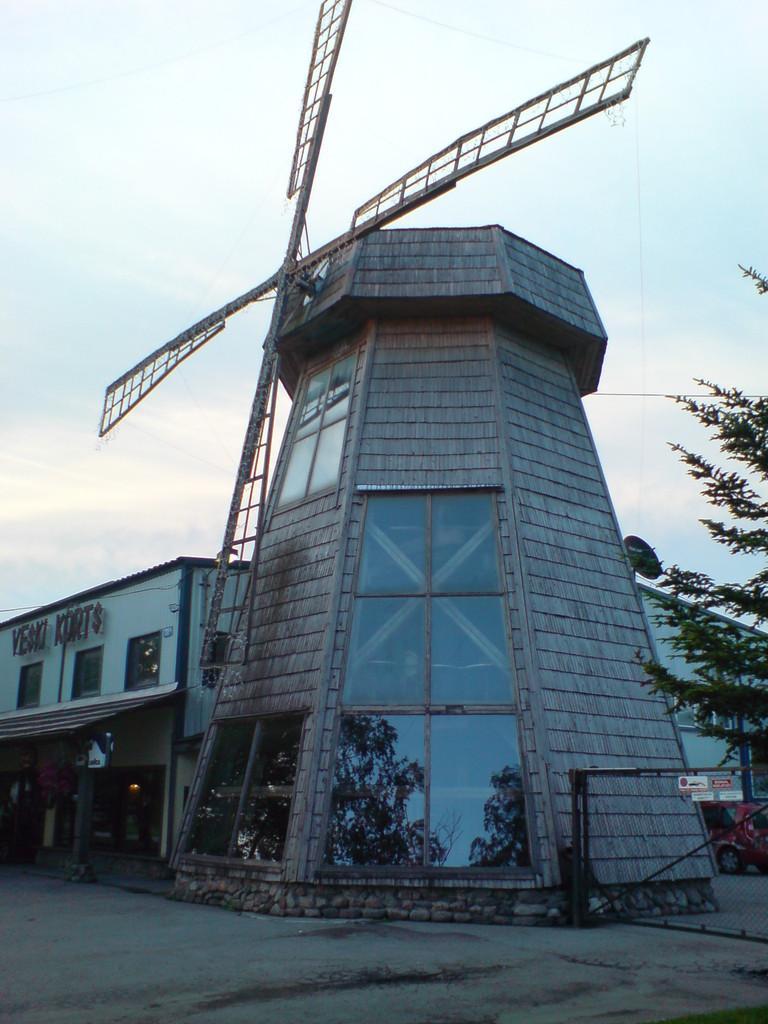In one or two sentences, can you explain what this image depicts? In this image I can see a windmill, a tree, a building and in background I can see clouds and the sky. Here I can see something is written. 